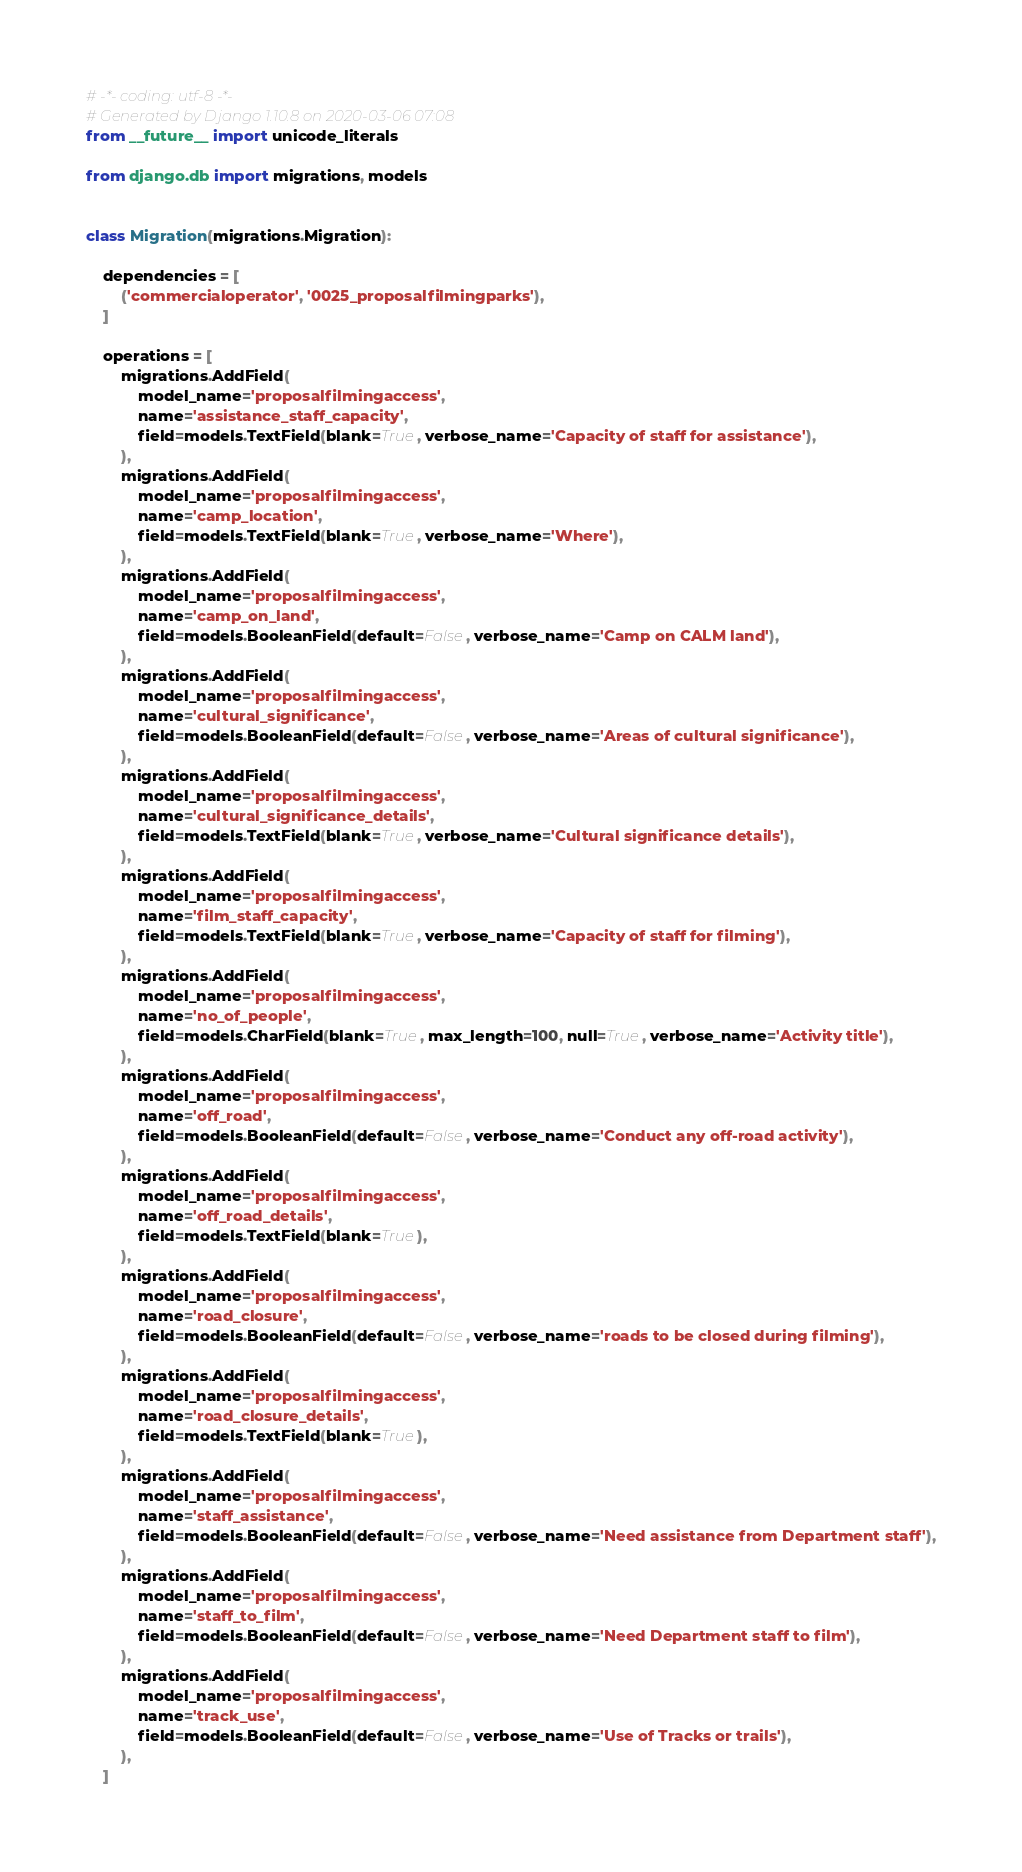<code> <loc_0><loc_0><loc_500><loc_500><_Python_># -*- coding: utf-8 -*-
# Generated by Django 1.10.8 on 2020-03-06 07:08
from __future__ import unicode_literals

from django.db import migrations, models


class Migration(migrations.Migration):

    dependencies = [
        ('commercialoperator', '0025_proposalfilmingparks'),
    ]

    operations = [
        migrations.AddField(
            model_name='proposalfilmingaccess',
            name='assistance_staff_capacity',
            field=models.TextField(blank=True, verbose_name='Capacity of staff for assistance'),
        ),
        migrations.AddField(
            model_name='proposalfilmingaccess',
            name='camp_location',
            field=models.TextField(blank=True, verbose_name='Where'),
        ),
        migrations.AddField(
            model_name='proposalfilmingaccess',
            name='camp_on_land',
            field=models.BooleanField(default=False, verbose_name='Camp on CALM land'),
        ),
        migrations.AddField(
            model_name='proposalfilmingaccess',
            name='cultural_significance',
            field=models.BooleanField(default=False, verbose_name='Areas of cultural significance'),
        ),
        migrations.AddField(
            model_name='proposalfilmingaccess',
            name='cultural_significance_details',
            field=models.TextField(blank=True, verbose_name='Cultural significance details'),
        ),
        migrations.AddField(
            model_name='proposalfilmingaccess',
            name='film_staff_capacity',
            field=models.TextField(blank=True, verbose_name='Capacity of staff for filming'),
        ),
        migrations.AddField(
            model_name='proposalfilmingaccess',
            name='no_of_people',
            field=models.CharField(blank=True, max_length=100, null=True, verbose_name='Activity title'),
        ),
        migrations.AddField(
            model_name='proposalfilmingaccess',
            name='off_road',
            field=models.BooleanField(default=False, verbose_name='Conduct any off-road activity'),
        ),
        migrations.AddField(
            model_name='proposalfilmingaccess',
            name='off_road_details',
            field=models.TextField(blank=True),
        ),
        migrations.AddField(
            model_name='proposalfilmingaccess',
            name='road_closure',
            field=models.BooleanField(default=False, verbose_name='roads to be closed during filming'),
        ),
        migrations.AddField(
            model_name='proposalfilmingaccess',
            name='road_closure_details',
            field=models.TextField(blank=True),
        ),
        migrations.AddField(
            model_name='proposalfilmingaccess',
            name='staff_assistance',
            field=models.BooleanField(default=False, verbose_name='Need assistance from Department staff'),
        ),
        migrations.AddField(
            model_name='proposalfilmingaccess',
            name='staff_to_film',
            field=models.BooleanField(default=False, verbose_name='Need Department staff to film'),
        ),
        migrations.AddField(
            model_name='proposalfilmingaccess',
            name='track_use',
            field=models.BooleanField(default=False, verbose_name='Use of Tracks or trails'),
        ),
    ]
</code> 